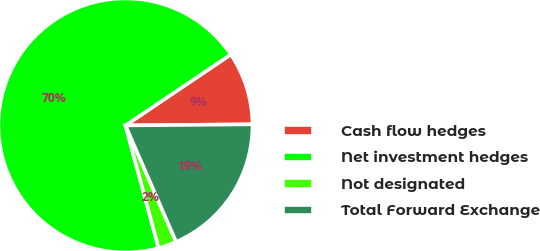<chart> <loc_0><loc_0><loc_500><loc_500><pie_chart><fcel>Cash flow hedges<fcel>Net investment hedges<fcel>Not designated<fcel>Total Forward Exchange<nl><fcel>9.3%<fcel>69.77%<fcel>2.33%<fcel>18.6%<nl></chart> 